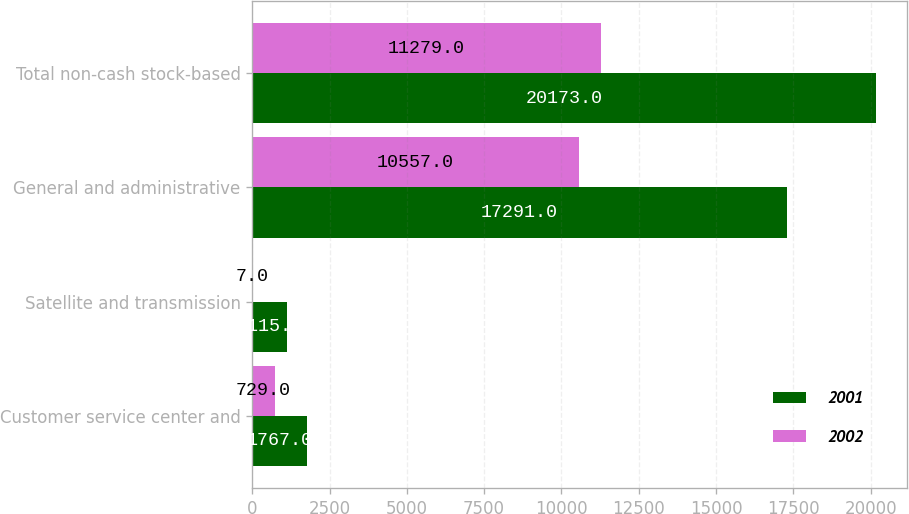Convert chart to OTSL. <chart><loc_0><loc_0><loc_500><loc_500><stacked_bar_chart><ecel><fcel>Customer service center and<fcel>Satellite and transmission<fcel>General and administrative<fcel>Total non-cash stock-based<nl><fcel>2001<fcel>1767<fcel>1115<fcel>17291<fcel>20173<nl><fcel>2002<fcel>729<fcel>7<fcel>10557<fcel>11279<nl></chart> 